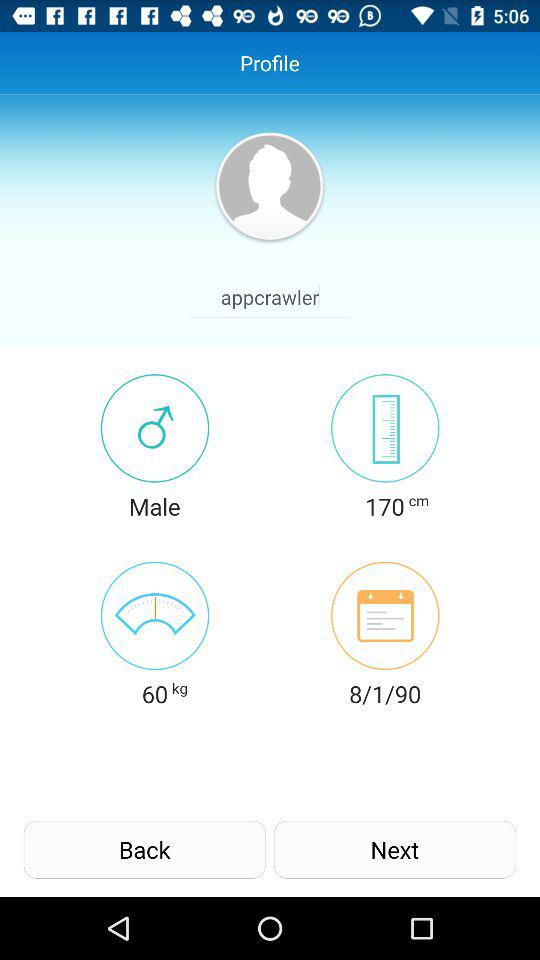How many more centimeters tall is the user than they weigh in kilograms?
Answer the question using a single word or phrase. 110 